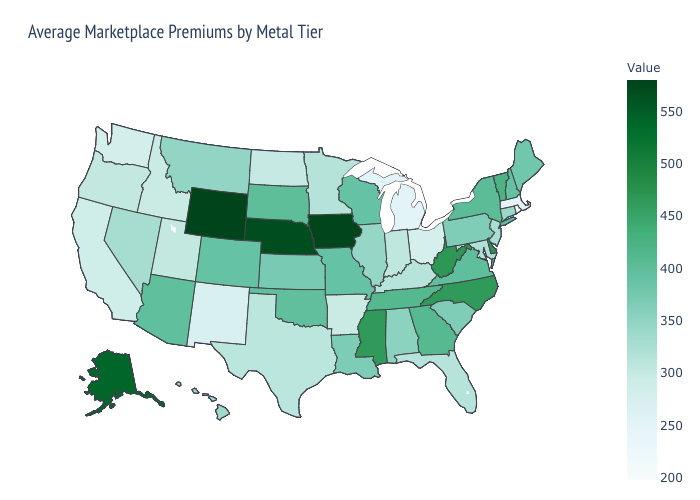Does Rhode Island have the lowest value in the USA?
Quick response, please. Yes. Does Iowa have the highest value in the MidWest?
Write a very short answer. Yes. Does Rhode Island have the lowest value in the USA?
Keep it brief. Yes. Does the map have missing data?
Be succinct. No. Among the states that border Kansas , which have the lowest value?
Short answer required. Colorado, Missouri. Which states hav the highest value in the MidWest?
Short answer required. Iowa. 